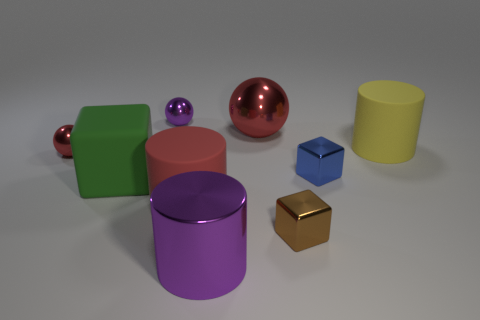What is the size of the matte cylinder that is to the left of the brown object?
Offer a very short reply. Large. Are there any other things that have the same color as the shiny cylinder?
Provide a succinct answer. Yes. Are there any red metallic things right of the metal cylinder in front of the red shiny sphere that is in front of the big yellow matte cylinder?
Offer a very short reply. Yes. Is the color of the large matte cylinder to the left of the purple cylinder the same as the large sphere?
Offer a terse response. Yes. How many cylinders are either small brown things or tiny blue objects?
Provide a succinct answer. 0. There is a purple object that is in front of the rubber cylinder behind the tiny red metal ball; what shape is it?
Provide a succinct answer. Cylinder. How big is the rubber cylinder in front of the green cube behind the purple metal object right of the small purple sphere?
Your answer should be very brief. Large. Do the yellow object and the purple shiny cylinder have the same size?
Your response must be concise. Yes. How many things are brown shiny cubes or large cylinders?
Give a very brief answer. 4. There is a red shiny sphere in front of the cylinder that is to the right of the small brown cube; what size is it?
Make the answer very short. Small. 